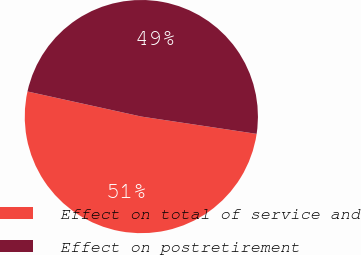Convert chart to OTSL. <chart><loc_0><loc_0><loc_500><loc_500><pie_chart><fcel>Effect on total of service and<fcel>Effect on postretirement<nl><fcel>51.08%<fcel>48.92%<nl></chart> 